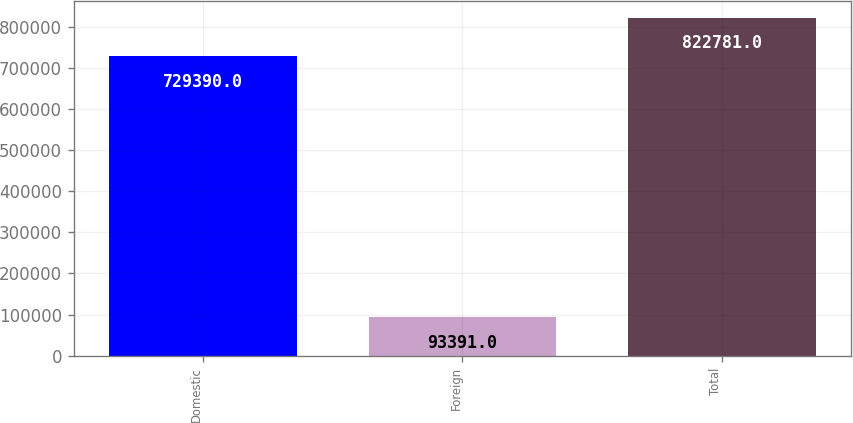Convert chart. <chart><loc_0><loc_0><loc_500><loc_500><bar_chart><fcel>Domestic<fcel>Foreign<fcel>Total<nl><fcel>729390<fcel>93391<fcel>822781<nl></chart> 